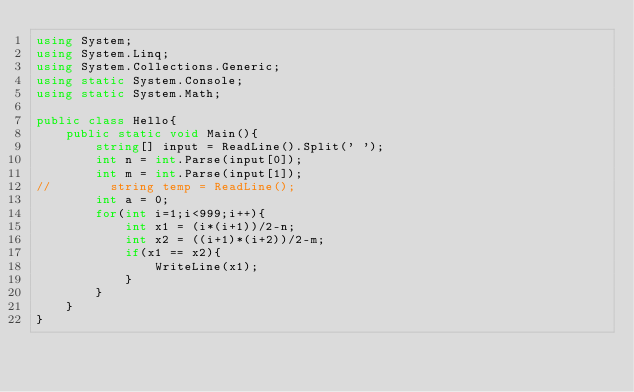<code> <loc_0><loc_0><loc_500><loc_500><_C#_>using System;
using System.Linq;
using System.Collections.Generic;
using static System.Console;
using static System.Math;
 
public class Hello{
    public static void Main(){
        string[] input = ReadLine().Split(' ');
        int n = int.Parse(input[0]);
        int m = int.Parse(input[1]);
//        string temp = ReadLine();
        int a = 0;
        for(int i=1;i<999;i++){
            int x1 = (i*(i+1))/2-n;
            int x2 = ((i+1)*(i+2))/2-m;
            if(x1 == x2){
                WriteLine(x1);
            }
        }
    }
}</code> 